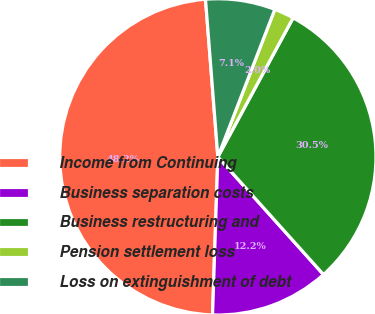<chart> <loc_0><loc_0><loc_500><loc_500><pie_chart><fcel>Income from Continuing<fcel>Business separation costs<fcel>Business restructuring and<fcel>Pension settlement loss<fcel>Loss on extinguishment of debt<nl><fcel>48.22%<fcel>12.18%<fcel>30.46%<fcel>2.03%<fcel>7.11%<nl></chart> 